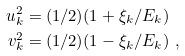<formula> <loc_0><loc_0><loc_500><loc_500>u _ { k } ^ { 2 } & = ( 1 / 2 ) ( 1 + \xi _ { k } / E _ { k } ) \\ v _ { k } ^ { 2 } & = ( 1 / 2 ) ( 1 - \xi _ { k } / E _ { k } ) \ ,</formula> 